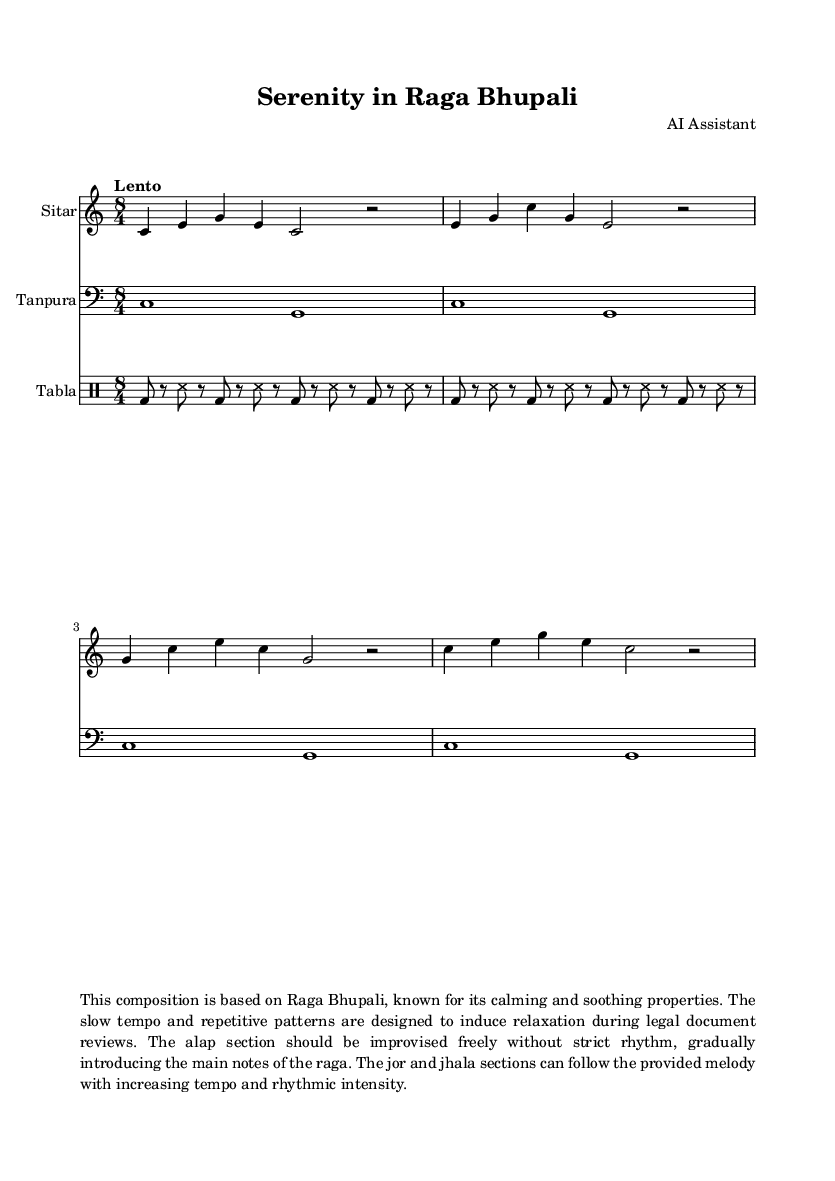What is the key signature of this music? The key signature is indicated in the global settings of the sheet music, which is C major. C major has no sharps or flats, which can be confirmed by looking at the key signature section.
Answer: C major What is the time signature of this piece? The time signature is provided in the global settings section of the sheet music, which states 8/4. This means there are 8 beats in a measure and the quarter note gets the beat.
Answer: 8/4 What is the tempo marking for this composition? The tempo marking is stated as "Lento" in the global settings. "Lento" suggests a slow tempo, which helps create a calming atmosphere suitable for relaxation.
Answer: Lento Which raga is this composition based on? The composition is based on Raga Bhupali, which is mentioned in the title and the notation, along with a description in the markup section. This specific raga is known for its calming properties.
Answer: Raga Bhupali How many measures are present in the sitar part? The sitar part contains a total of four measures, which can be counted from both the notation itself and the way it is divided in the score.
Answer: 4 What instruments are included in this music score? The instruments listed in the score are Sitar, Tanpura, and Tabla. Each instrument has its own dedicated staff, which is clearly labeled at the beginning of each section in the score.
Answer: Sitar, Tanpura, Tabla What is the rhythmic pattern of the tabla? The rhythmic pattern for the tabla part can be seen in the drummode section, where it is represented by alternating bass and splash sounds (bd and ss). Reviewing the rhythmic notation shows a repeated sequence across the measures.
Answer: bd8 r8 ss8 